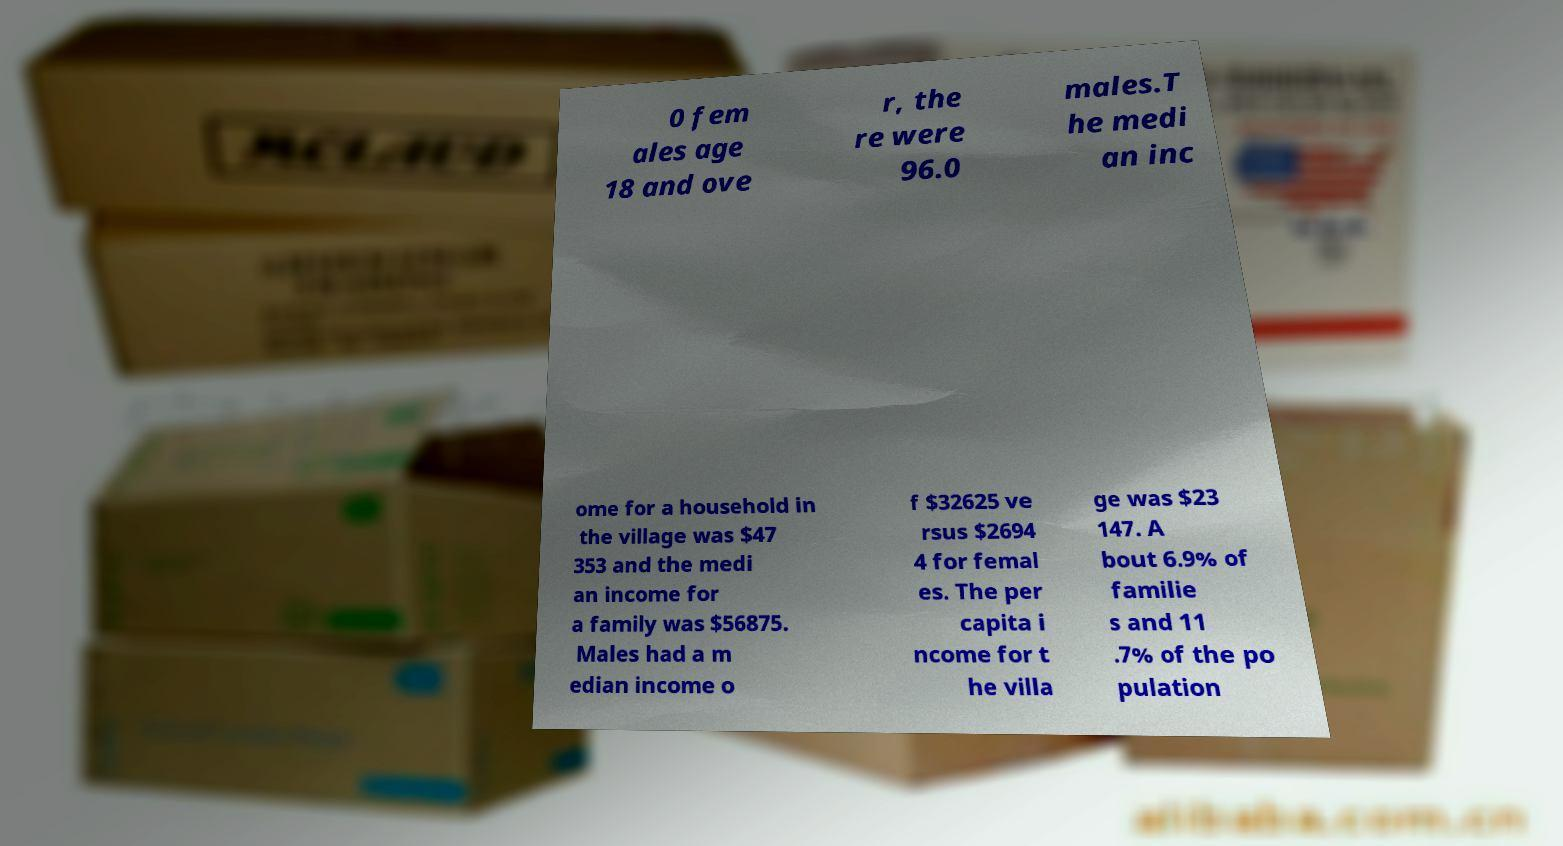Can you read and provide the text displayed in the image?This photo seems to have some interesting text. Can you extract and type it out for me? 0 fem ales age 18 and ove r, the re were 96.0 males.T he medi an inc ome for a household in the village was $47 353 and the medi an income for a family was $56875. Males had a m edian income o f $32625 ve rsus $2694 4 for femal es. The per capita i ncome for t he villa ge was $23 147. A bout 6.9% of familie s and 11 .7% of the po pulation 